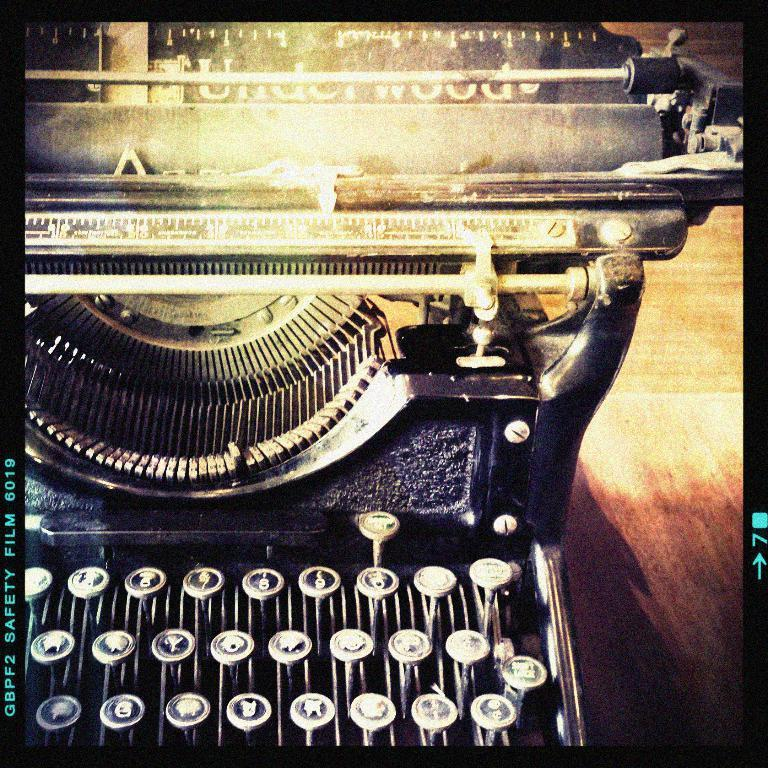What is the main object on the table in the image? There is a typewriter on a table in the image. What can be seen on the left side of the image? There is a watermark on the left side of the image. What type of operation is being performed on the typewriter in the image? There is no indication of any operation being performed on the typewriter in the image. Can you find any verses or poems written on the typewriter in the image? There is no visible text or writing on the typewriter in the image. 